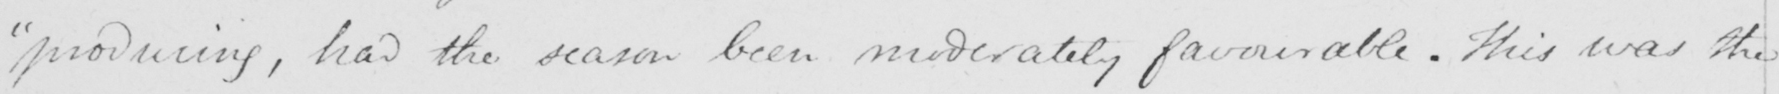Can you tell me what this handwritten text says? producing , had the season been moderately favourable . This was the 